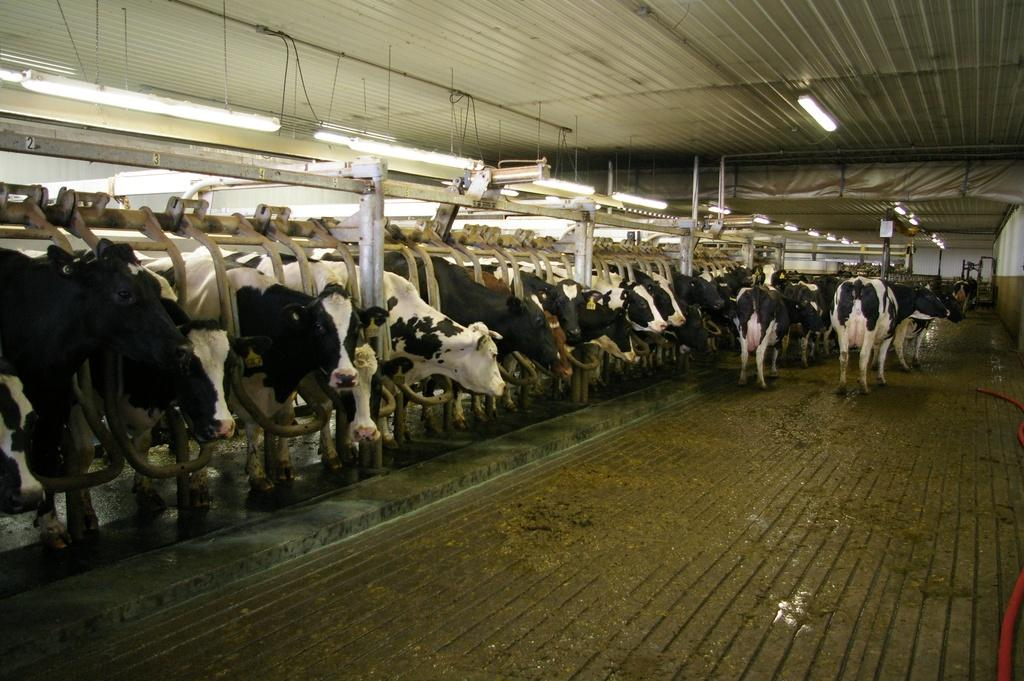What is the main subject of the image? The main subject of the image is a group of animals. What can be seen hanging in the image? There are lights hanging in the image. What type of structures are present in the image? There are stands in the image. What type of disease is affecting the animals in the image? There is no indication of any disease affecting the animals in the image. What type of root can be seen growing from the stands in the image? There are no roots visible in the image, as the stands are likely man-made structures. 